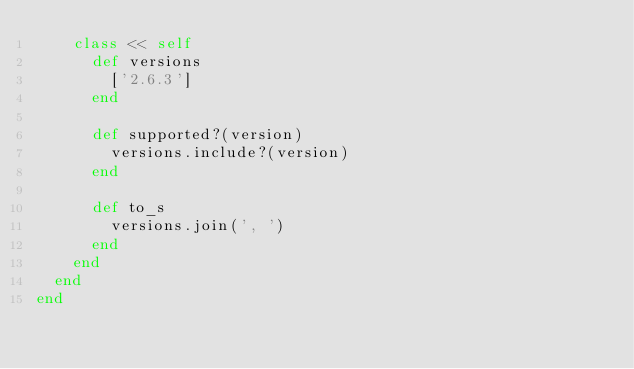Convert code to text. <code><loc_0><loc_0><loc_500><loc_500><_Ruby_>    class << self
      def versions
        ['2.6.3']
      end

      def supported?(version)
        versions.include?(version)
      end

      def to_s
        versions.join(', ')
      end
    end
  end
end
</code> 